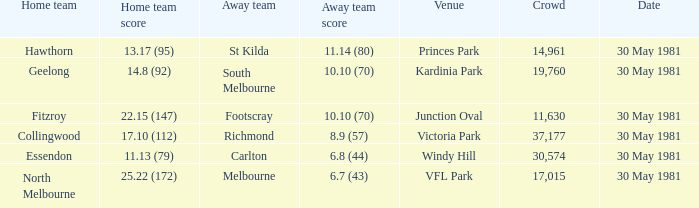What did carlton score while away? 6.8 (44). 